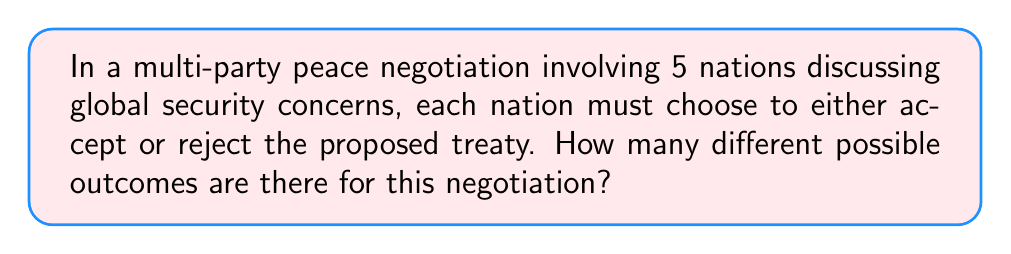Teach me how to tackle this problem. To solve this problem, we need to consider the following:

1. Each nation has two choices: accept or reject the treaty.
2. The total number of nations involved is 5.
3. We need to determine the number of possible combinations of these choices.

This scenario can be modeled as a combination problem with repetition, specifically a case of binary choices for each participant.

For each nation, there are 2 possible choices. Since there are 5 nations, and each nation's choice is independent of the others, we can use the multiplication principle.

The total number of possible outcomes is:

$$ 2 \times 2 \times 2 \times 2 \times 2 = 2^5 $$

We can also think of this as a binary string of length 5, where each position represents a nation, and the value (0 or 1) represents their choice (reject or accept).

To calculate $2^5$:

$$ 2^5 = 2 \times 2 \times 2 \times 2 \times 2 = 32 $$

Therefore, there are 32 possible outcomes for this multi-party peace negotiation.
Answer: $32$ 